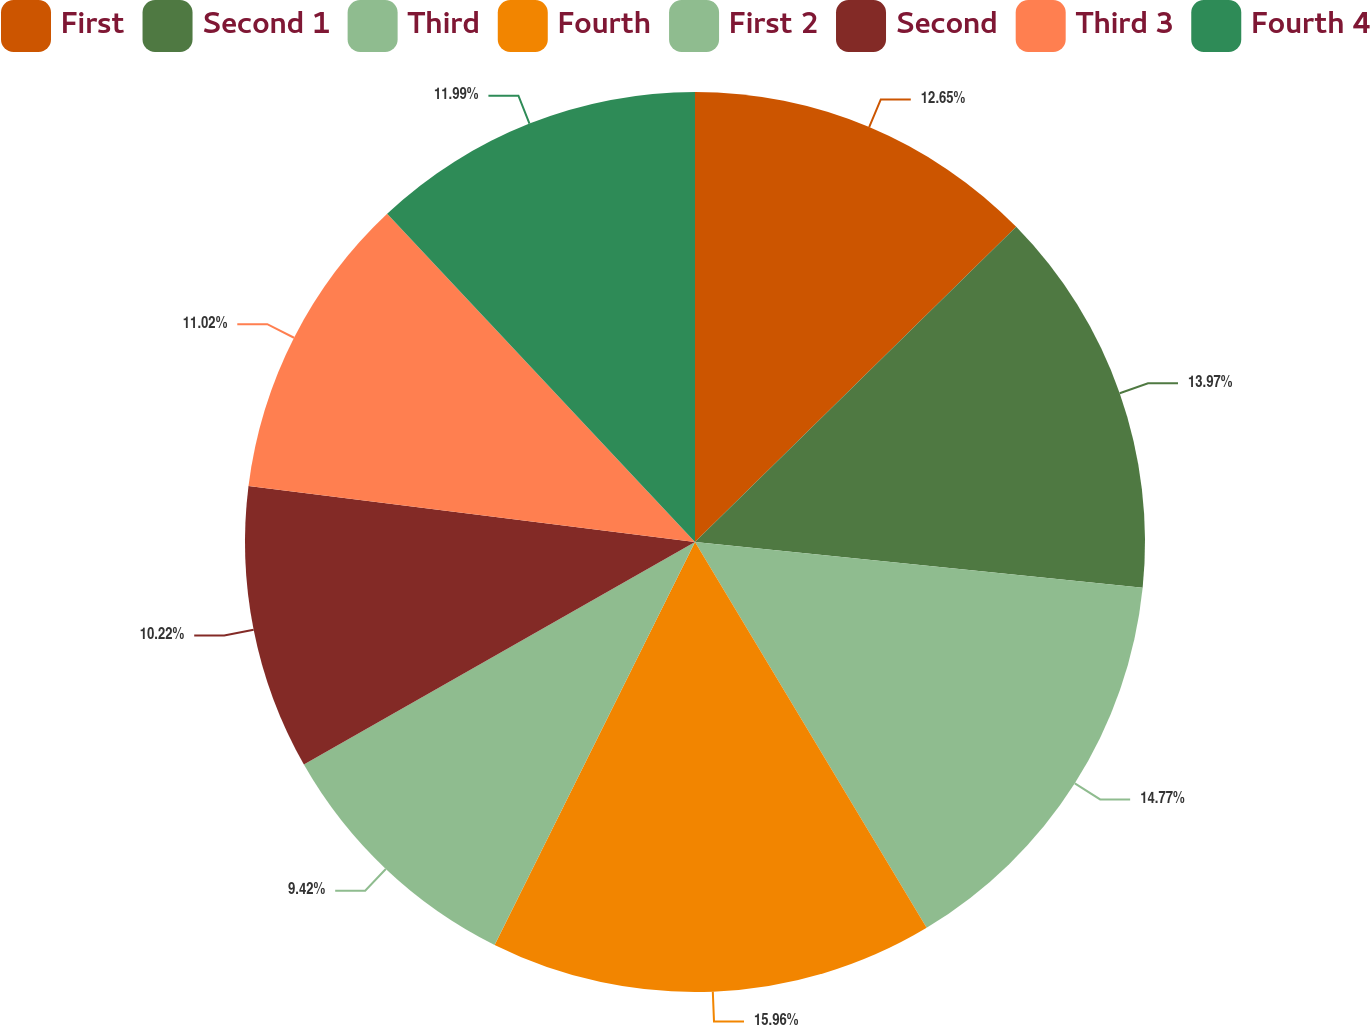<chart> <loc_0><loc_0><loc_500><loc_500><pie_chart><fcel>First<fcel>Second 1<fcel>Third<fcel>Fourth<fcel>First 2<fcel>Second<fcel>Third 3<fcel>Fourth 4<nl><fcel>12.65%<fcel>13.97%<fcel>14.77%<fcel>15.95%<fcel>9.42%<fcel>10.22%<fcel>11.02%<fcel>11.99%<nl></chart> 